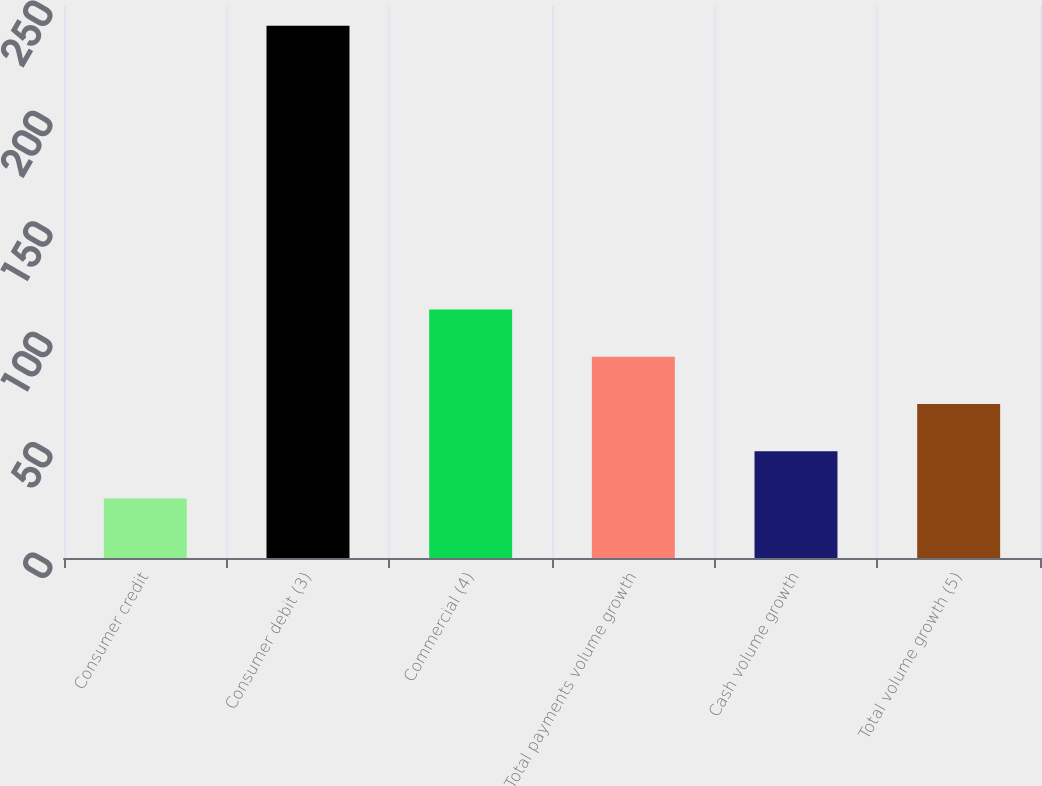Convert chart. <chart><loc_0><loc_0><loc_500><loc_500><bar_chart><fcel>Consumer credit<fcel>Consumer debit (3)<fcel>Commercial (4)<fcel>Total payments volume growth<fcel>Cash volume growth<fcel>Total volume growth (5)<nl><fcel>27<fcel>241<fcel>112.6<fcel>91.2<fcel>48.4<fcel>69.8<nl></chart> 